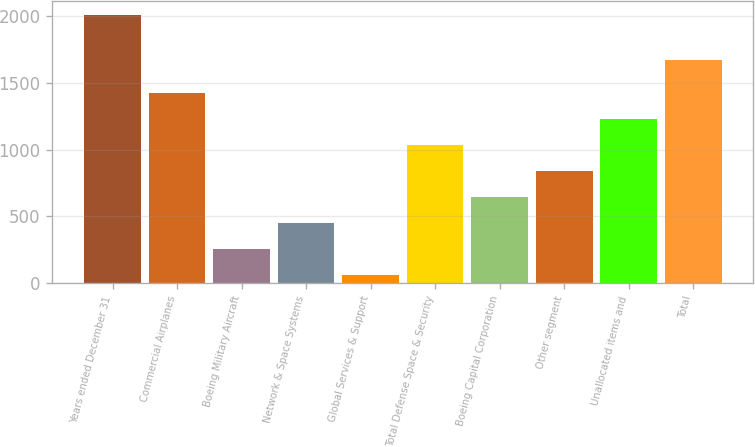Convert chart. <chart><loc_0><loc_0><loc_500><loc_500><bar_chart><fcel>Years ended December 31<fcel>Commercial Airplanes<fcel>Boeing Military Aircraft<fcel>Network & Space Systems<fcel>Global Services & Support<fcel>Total Defense Space & Security<fcel>Boeing Capital Corporation<fcel>Other segment<fcel>Unallocated items and<fcel>Total<nl><fcel>2011<fcel>1426.3<fcel>256.9<fcel>451.8<fcel>62<fcel>1036.5<fcel>646.7<fcel>841.6<fcel>1231.4<fcel>1675<nl></chart> 